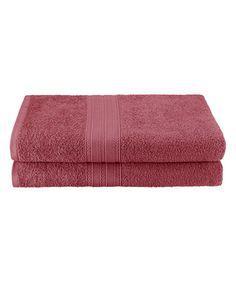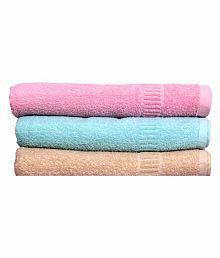The first image is the image on the left, the second image is the image on the right. Evaluate the accuracy of this statement regarding the images: "There is a stack of at least five different colored towels.". Is it true? Answer yes or no. No. 